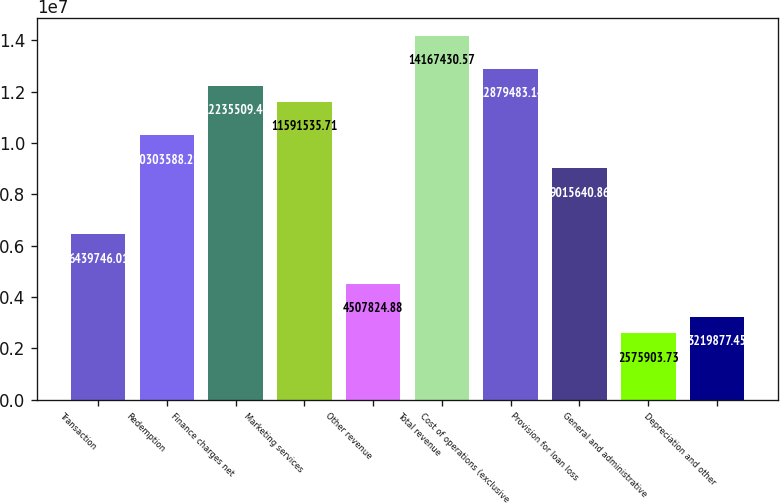<chart> <loc_0><loc_0><loc_500><loc_500><bar_chart><fcel>Transaction<fcel>Redemption<fcel>Finance charges net<fcel>Marketing services<fcel>Other revenue<fcel>Total revenue<fcel>Cost of operations (exclusive<fcel>Provision for loan loss<fcel>General and administrative<fcel>Depreciation and other<nl><fcel>6.43975e+06<fcel>1.03036e+07<fcel>1.22355e+07<fcel>1.15915e+07<fcel>4.50782e+06<fcel>1.41674e+07<fcel>1.28795e+07<fcel>9.01564e+06<fcel>2.5759e+06<fcel>3.21988e+06<nl></chart> 